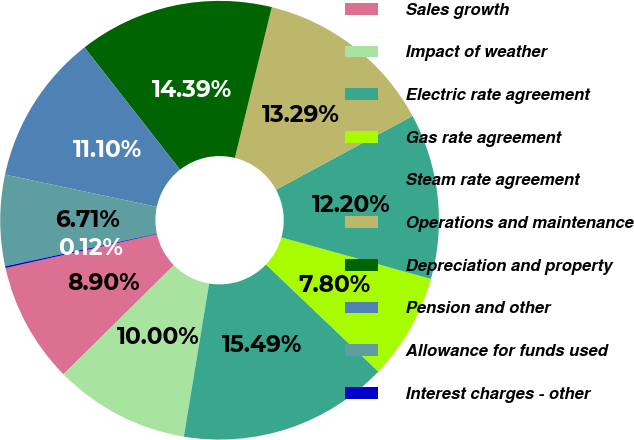Convert chart to OTSL. <chart><loc_0><loc_0><loc_500><loc_500><pie_chart><fcel>Sales growth<fcel>Impact of weather<fcel>Electric rate agreement<fcel>Gas rate agreement<fcel>Steam rate agreement<fcel>Operations and maintenance<fcel>Depreciation and property<fcel>Pension and other<fcel>Allowance for funds used<fcel>Interest charges - other<nl><fcel>8.9%<fcel>10.0%<fcel>15.49%<fcel>7.8%<fcel>12.2%<fcel>13.29%<fcel>14.39%<fcel>11.1%<fcel>6.71%<fcel>0.12%<nl></chart> 